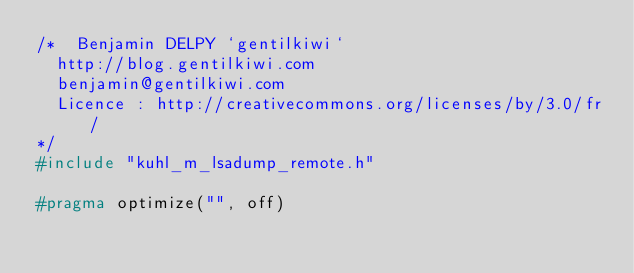<code> <loc_0><loc_0><loc_500><loc_500><_C_>/*	Benjamin DELPY `gentilkiwi`
	http://blog.gentilkiwi.com
	benjamin@gentilkiwi.com
	Licence : http://creativecommons.org/licenses/by/3.0/fr/
*/
#include "kuhl_m_lsadump_remote.h"

#pragma optimize("", off)</code> 